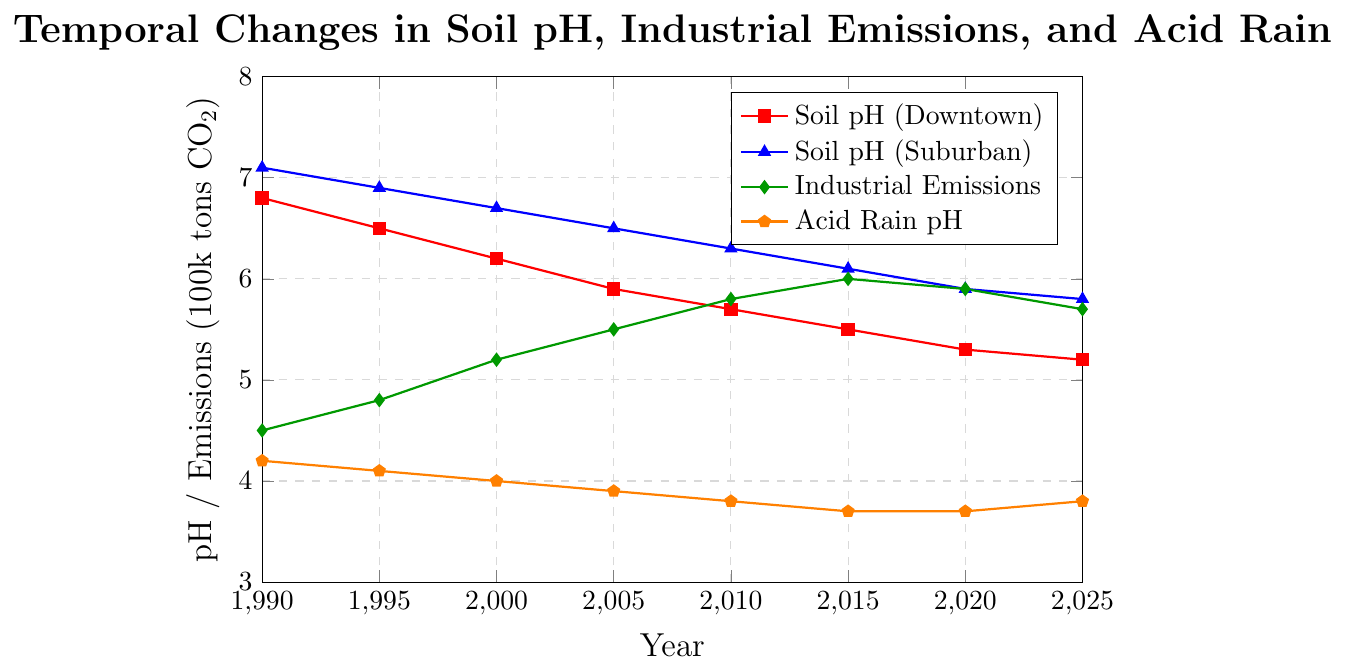Which year shows the lowest soil pH level in the downtown area? To determine this, we look at the trend for the "Soil pH (Downtown)" line and find the lowest point on the y-axis over time. The lowest point is in 2025.
Answer: 2025 How did the soil pH levels in the suburban area change from 1990 to 2025? Observe the "Soil pH (Suburban)" line from 1990 to 2025. Initially, it's at 7.1 in 1990, gradually decreasing over time to 5.8 in 2025.
Answer: Decreased In which year did industrial emissions peak? Check the "Industrial Emissions" line to see the highest point on the y-axis. This occurs in 2015 at 6.0 (600000 tons CO2).
Answer: 2015 How does the soil pH in downtown compare to the suburban for the year 2015? Compare the "Soil pH (Downtown)" and "Soil pH (Suburban)" values for 2015. Downtown's pH is 5.5 and Suburban's pH is 6.1.
Answer: Downtown pH is lower What is the difference in soil pH levels between downtown and suburban areas in 2020? Find the values for both areas for 2020: Downtown pH is 5.3 and Suburban pH is 5.9. Subtract 5.3 from 5.9 to find the difference.
Answer: 0.6 Describe the trend of acid rain pH levels from 1990 to 2025. Look at the "Acid Rain pH" line from 1990 to 2025. It starts at 4.2 in 1990, decreasing to 3.7 by 2015, and then slightly rising to 3.8 by 2025.
Answer: Decreasing then slightly increasing What's the approximate average soil pH level in downtown from 1990 to 2025? Sum the pH values for downtown from 1990 (6.8), 1995 (6.5), 2000 (6.2), 2005 (5.9), 2010 (5.7), 2015 (5.5), 2020 (5.3), and 2025 (5.2) and divide by 8. \( \frac{6.8 + 6.5 + 6.2 + 5.9 + 5.7 + 5.5 + 5.3 + 5.2}{8} = 5.89 \)
Answer: 5.89 Were there years where the suburban soil pH remained constant? Observe the "Soil pH (Suburban)" line for any flat segments. From 2020 to 2025, the suburban pH remains at 5.9 for two years.
Answer: Yes, between 2020 and 2025 Which component shows the most significant decline from 1990 to 2025? Examine the lines for downtown soil pH, suburban soil pH, industrial emissions, and acid rain pH. The "Soil pH (Downtown)" line shows the most significant decline from 6.8 to 5.2, a total of 1.6 units.
Answer: Soil pH (Downtown) How does industrial emissions' trend correlate with the soil pH levels in downtown areas? Notice the general trend: as "Industrial Emissions" increase from 1990 to 2015, "Soil pH (Downtown)" decreases, indicating a negative correlation.
Answer: Negative correlation 